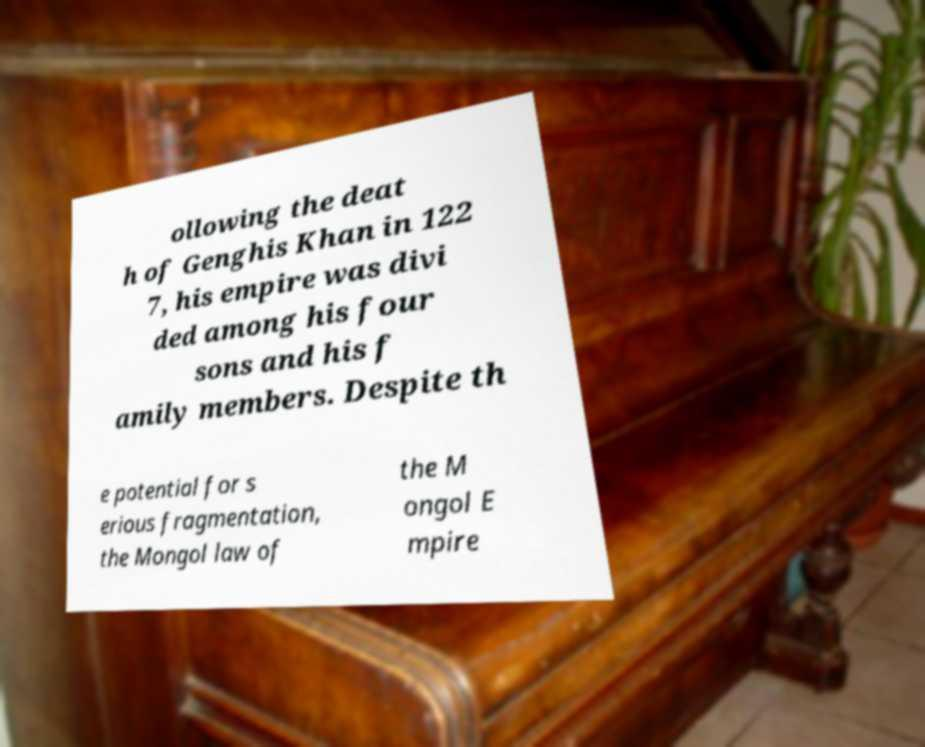Can you read and provide the text displayed in the image?This photo seems to have some interesting text. Can you extract and type it out for me? ollowing the deat h of Genghis Khan in 122 7, his empire was divi ded among his four sons and his f amily members. Despite th e potential for s erious fragmentation, the Mongol law of the M ongol E mpire 